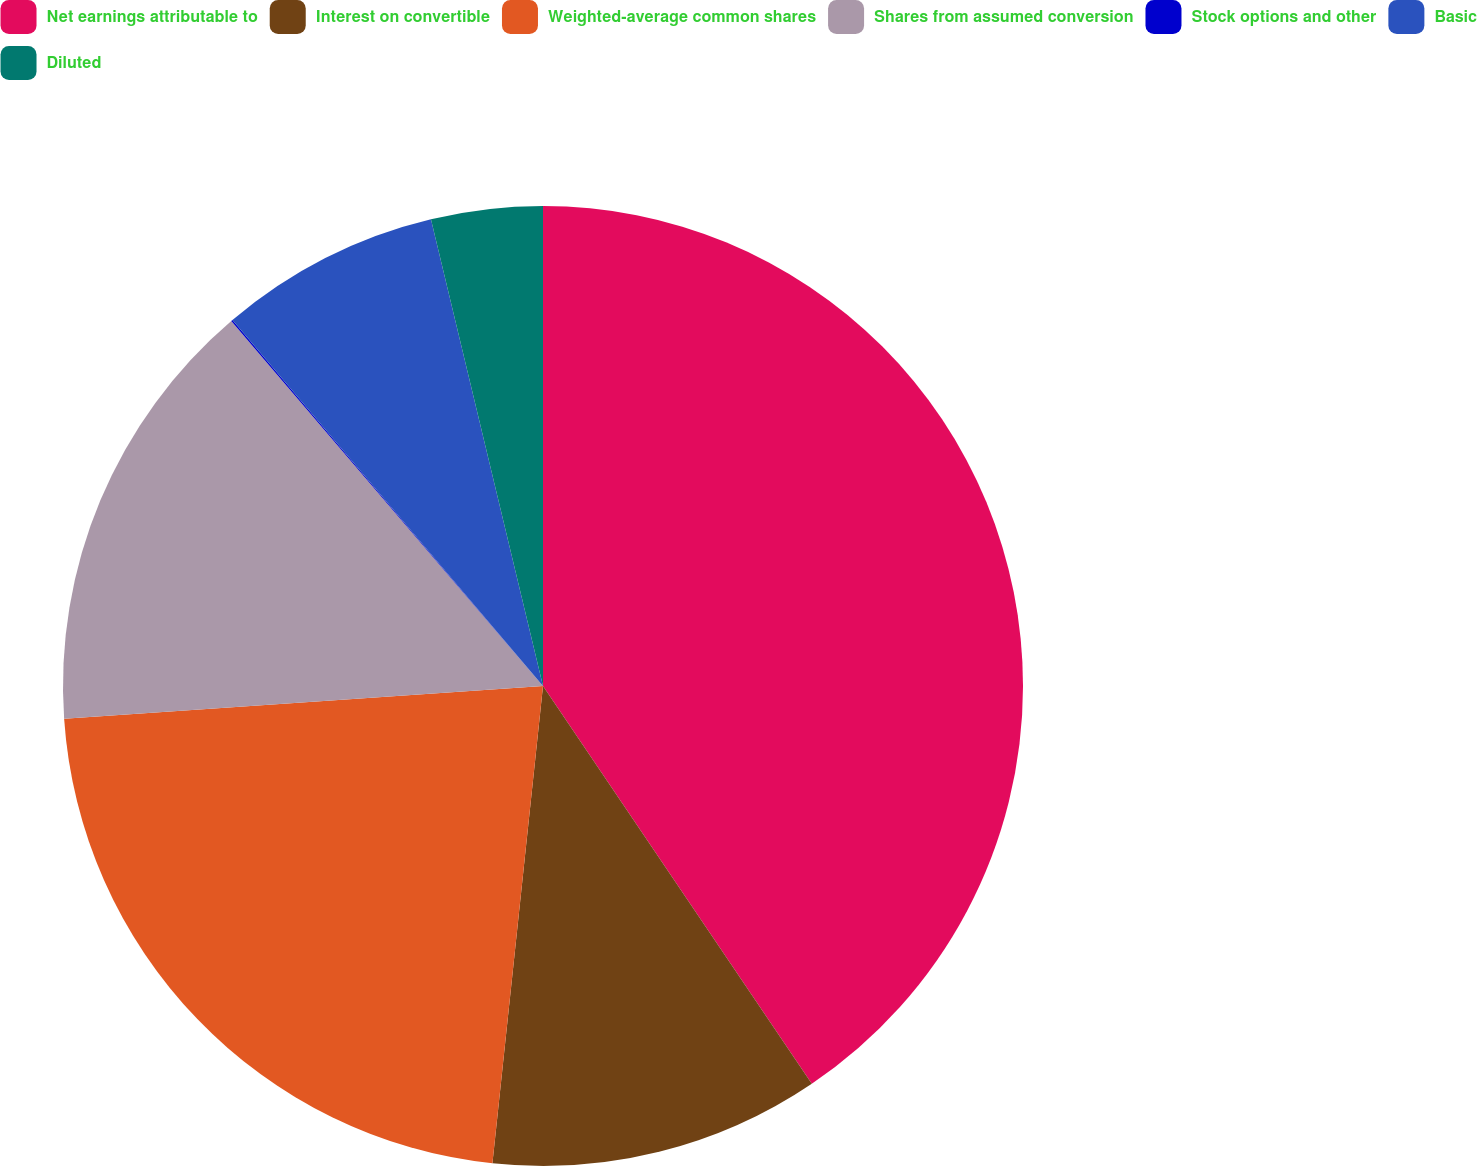Convert chart to OTSL. <chart><loc_0><loc_0><loc_500><loc_500><pie_chart><fcel>Net earnings attributable to<fcel>Interest on convertible<fcel>Weighted-average common shares<fcel>Shares from assumed conversion<fcel>Stock options and other<fcel>Basic<fcel>Diluted<nl><fcel>40.54%<fcel>11.14%<fcel>22.23%<fcel>14.84%<fcel>0.05%<fcel>7.45%<fcel>3.75%<nl></chart> 